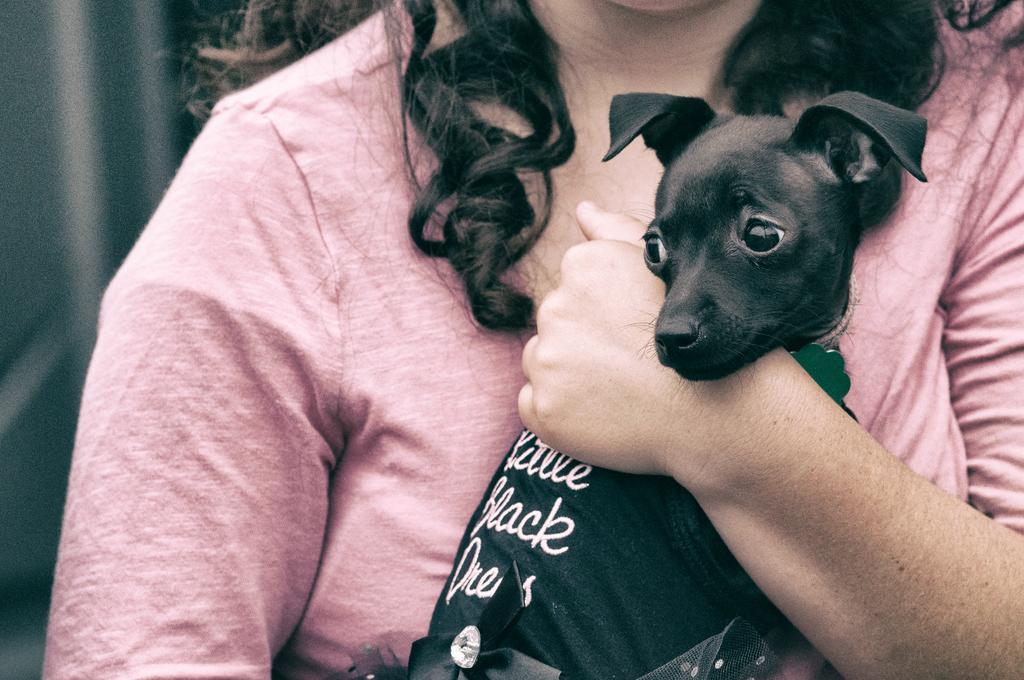Could you give a brief overview of what you see in this image? In the image there is a woman in peach color dress holding a black dog. 